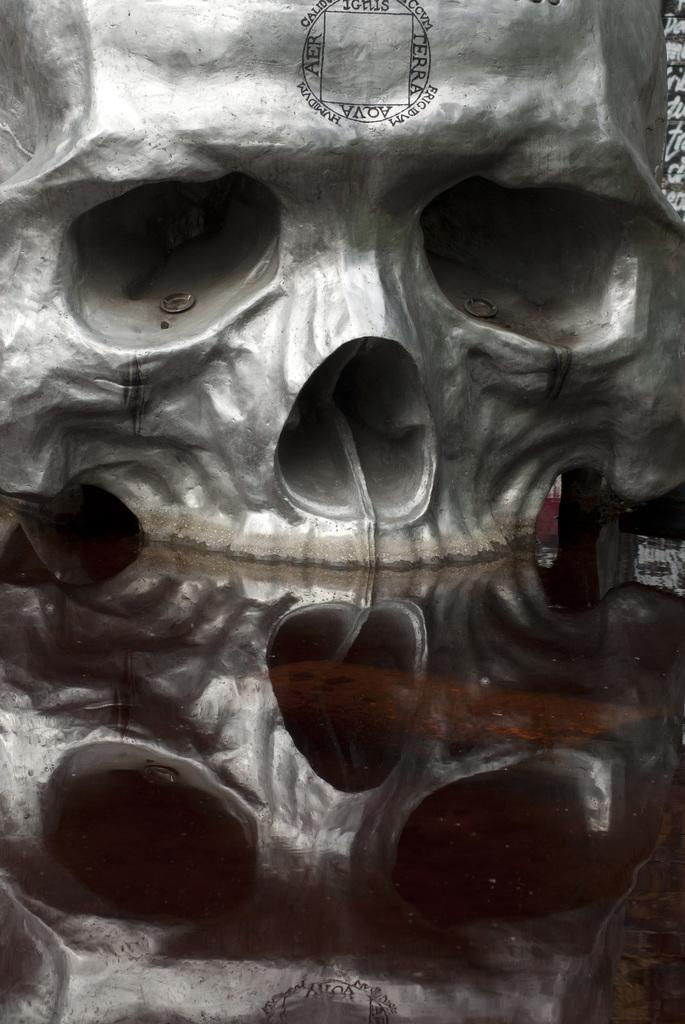What is the main subject of the image? The main subject of the image is a skull. Is there anything else related to the skull in the image? Yes, there is a reflection of a skull at the bottom of the image. How does the skull grip the stream in the image? There is no stream present in the image, and skulls do not have the ability to grip anything. 